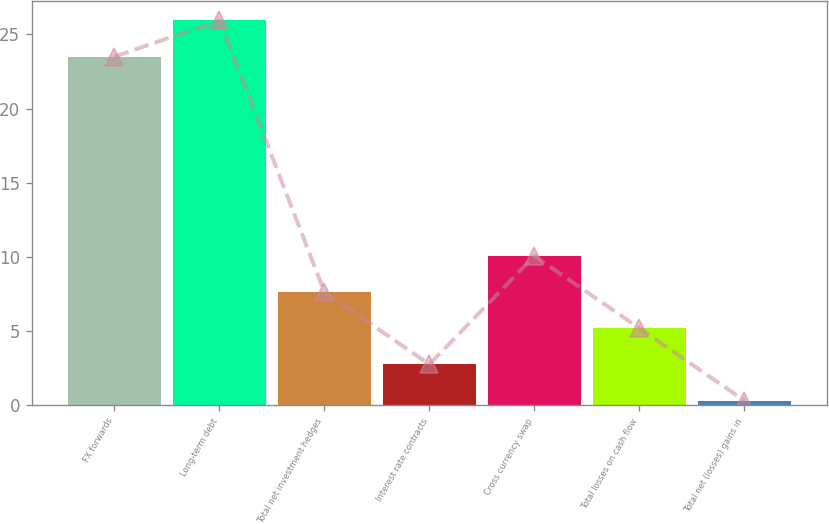Convert chart to OTSL. <chart><loc_0><loc_0><loc_500><loc_500><bar_chart><fcel>FX forwards<fcel>Long-term debt<fcel>Total net investment hedges<fcel>Interest rate contracts<fcel>Cross currency swap<fcel>Total losses on cash flow<fcel>Total net (losses) gains in<nl><fcel>23.5<fcel>25.94<fcel>7.62<fcel>2.74<fcel>10.06<fcel>5.18<fcel>0.3<nl></chart> 